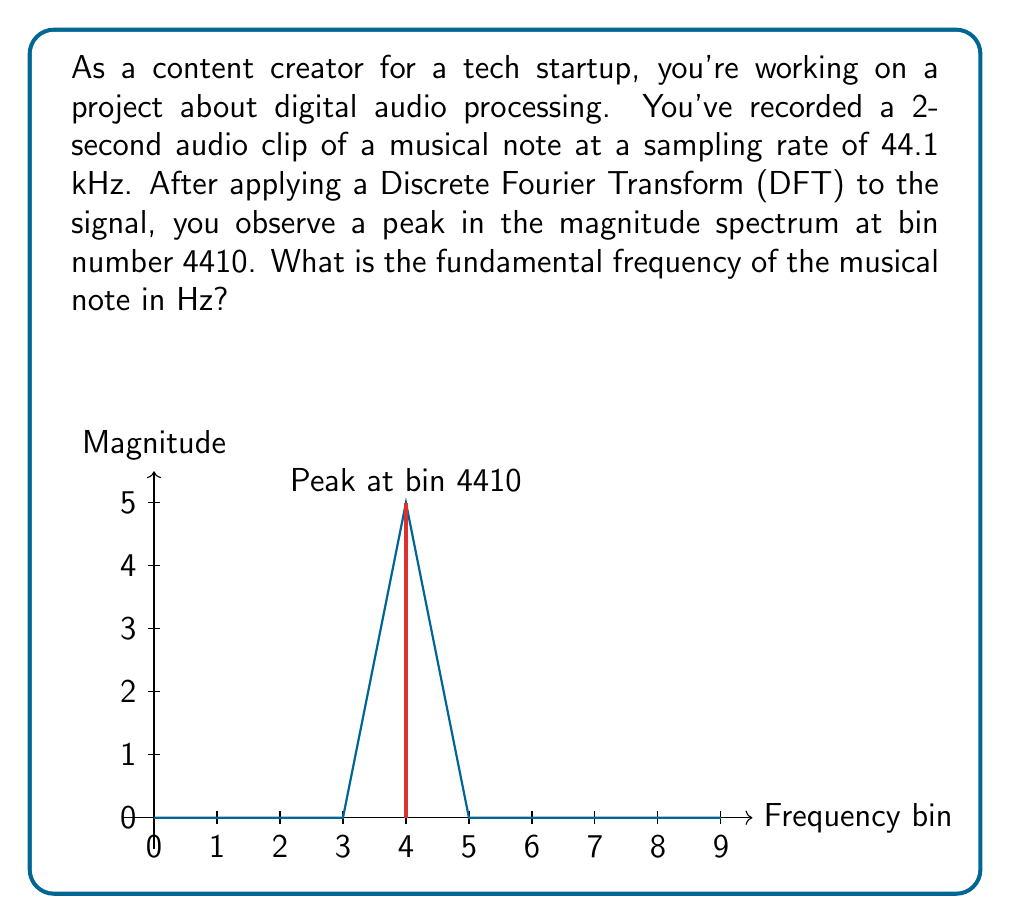Could you help me with this problem? To solve this problem, we need to understand the relationship between the DFT bin number, sampling rate, and frequency. Let's break it down step-by-step:

1) First, recall the formula for converting DFT bin number to frequency:

   $$f = \frac{k \cdot f_s}{N}$$

   Where:
   $f$ is the frequency in Hz
   $k$ is the bin number
   $f_s$ is the sampling rate
   $N$ is the total number of samples

2) We're given:
   - Sampling rate $f_s = 44.1$ kHz $= 44100$ Hz
   - Peak bin number $k = 4410$
   - Duration of the clip = 2 seconds

3) To find $N$ (total number of samples), we multiply the sampling rate by the duration:

   $$N = 44100 \text{ Hz} \cdot 2 \text{ s} = 88200 \text{ samples}$$

4) Now we can plug these values into our formula:

   $$f = \frac{4410 \cdot 44100}{88200}$$

5) Simplify:

   $$f = \frac{194481000}{88200} = 2205 \text{ Hz}$$

Therefore, the fundamental frequency of the musical note is 2205 Hz.
Answer: 2205 Hz 